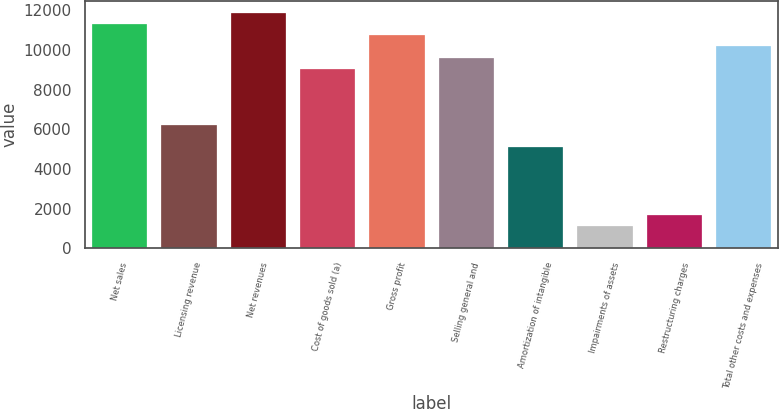Convert chart. <chart><loc_0><loc_0><loc_500><loc_500><bar_chart><fcel>Net sales<fcel>Licensing revenue<fcel>Net revenues<fcel>Cost of goods sold (a)<fcel>Gross profit<fcel>Selling general and<fcel>Amortization of intangible<fcel>Impairments of assets<fcel>Restructuring charges<fcel>Total other costs and expenses<nl><fcel>11320.1<fcel>6226.28<fcel>11886.1<fcel>9056.18<fcel>10754.1<fcel>9622.16<fcel>5094.32<fcel>1132.46<fcel>1698.44<fcel>10188.1<nl></chart> 